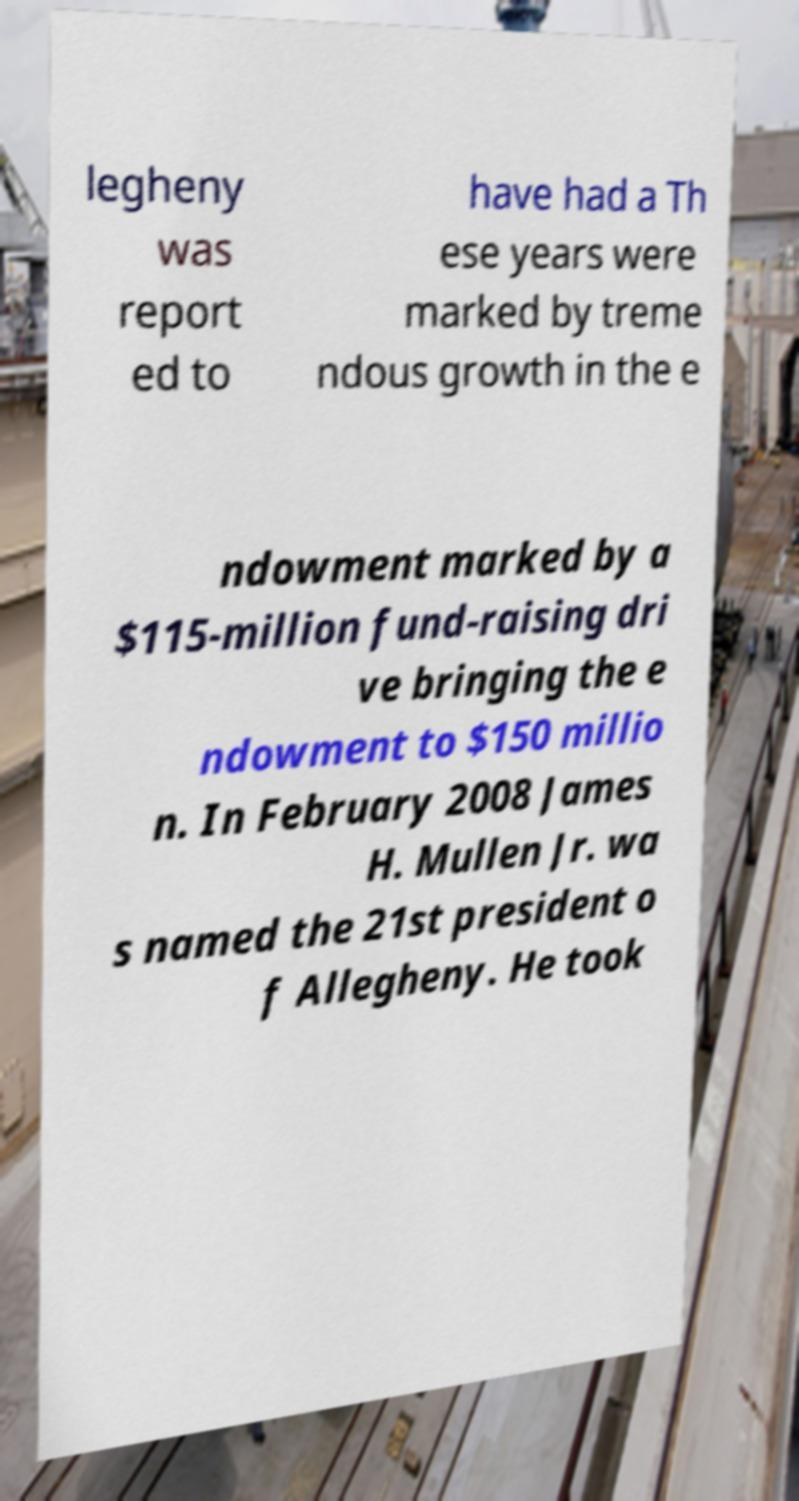Could you assist in decoding the text presented in this image and type it out clearly? legheny was report ed to have had a Th ese years were marked by treme ndous growth in the e ndowment marked by a $115-million fund-raising dri ve bringing the e ndowment to $150 millio n. In February 2008 James H. Mullen Jr. wa s named the 21st president o f Allegheny. He took 